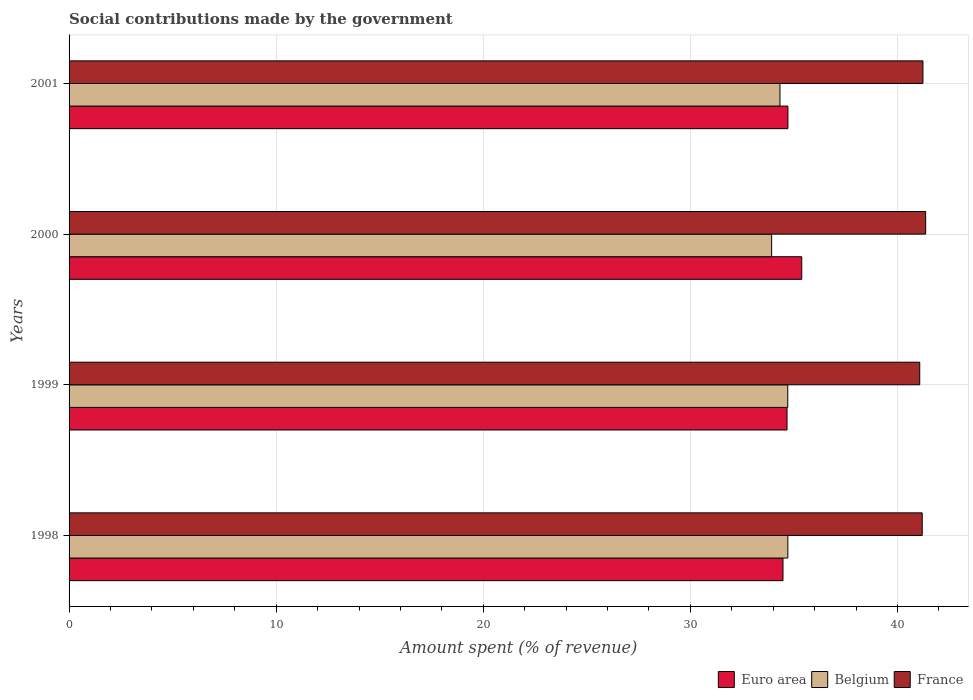How many different coloured bars are there?
Your response must be concise. 3. Are the number of bars per tick equal to the number of legend labels?
Keep it short and to the point. Yes. How many bars are there on the 2nd tick from the top?
Your answer should be very brief. 3. In how many cases, is the number of bars for a given year not equal to the number of legend labels?
Your answer should be compact. 0. What is the amount spent (in %) on social contributions in Euro area in 1998?
Offer a very short reply. 34.47. Across all years, what is the maximum amount spent (in %) on social contributions in Belgium?
Your response must be concise. 34.71. Across all years, what is the minimum amount spent (in %) on social contributions in France?
Your response must be concise. 41.08. In which year was the amount spent (in %) on social contributions in France maximum?
Your answer should be compact. 2000. What is the total amount spent (in %) on social contributions in Euro area in the graph?
Give a very brief answer. 139.23. What is the difference between the amount spent (in %) on social contributions in France in 1999 and that in 2001?
Ensure brevity in your answer.  -0.15. What is the difference between the amount spent (in %) on social contributions in France in 1998 and the amount spent (in %) on social contributions in Euro area in 2001?
Keep it short and to the point. 6.48. What is the average amount spent (in %) on social contributions in Belgium per year?
Your answer should be compact. 34.42. In the year 2001, what is the difference between the amount spent (in %) on social contributions in France and amount spent (in %) on social contributions in Euro area?
Offer a terse response. 6.52. What is the ratio of the amount spent (in %) on social contributions in Belgium in 1998 to that in 1999?
Make the answer very short. 1. Is the amount spent (in %) on social contributions in Euro area in 1999 less than that in 2000?
Your answer should be very brief. Yes. What is the difference between the highest and the second highest amount spent (in %) on social contributions in Belgium?
Ensure brevity in your answer.  0. What is the difference between the highest and the lowest amount spent (in %) on social contributions in France?
Your answer should be very brief. 0.29. What does the 3rd bar from the top in 2001 represents?
Your answer should be compact. Euro area. How many bars are there?
Make the answer very short. 12. How many years are there in the graph?
Ensure brevity in your answer.  4. What is the difference between two consecutive major ticks on the X-axis?
Provide a succinct answer. 10. Does the graph contain any zero values?
Offer a very short reply. No. Does the graph contain grids?
Give a very brief answer. Yes. Where does the legend appear in the graph?
Keep it short and to the point. Bottom right. How many legend labels are there?
Make the answer very short. 3. How are the legend labels stacked?
Offer a terse response. Horizontal. What is the title of the graph?
Offer a terse response. Social contributions made by the government. What is the label or title of the X-axis?
Provide a succinct answer. Amount spent (% of revenue). What is the label or title of the Y-axis?
Make the answer very short. Years. What is the Amount spent (% of revenue) of Euro area in 1998?
Provide a succinct answer. 34.47. What is the Amount spent (% of revenue) in Belgium in 1998?
Give a very brief answer. 34.71. What is the Amount spent (% of revenue) of France in 1998?
Provide a succinct answer. 41.2. What is the Amount spent (% of revenue) of Euro area in 1999?
Keep it short and to the point. 34.67. What is the Amount spent (% of revenue) of Belgium in 1999?
Your answer should be compact. 34.7. What is the Amount spent (% of revenue) of France in 1999?
Your answer should be compact. 41.08. What is the Amount spent (% of revenue) of Euro area in 2000?
Make the answer very short. 35.38. What is the Amount spent (% of revenue) of Belgium in 2000?
Ensure brevity in your answer.  33.93. What is the Amount spent (% of revenue) of France in 2000?
Ensure brevity in your answer.  41.36. What is the Amount spent (% of revenue) in Euro area in 2001?
Provide a short and direct response. 34.71. What is the Amount spent (% of revenue) of Belgium in 2001?
Ensure brevity in your answer.  34.33. What is the Amount spent (% of revenue) in France in 2001?
Offer a terse response. 41.23. Across all years, what is the maximum Amount spent (% of revenue) in Euro area?
Provide a short and direct response. 35.38. Across all years, what is the maximum Amount spent (% of revenue) in Belgium?
Your answer should be compact. 34.71. Across all years, what is the maximum Amount spent (% of revenue) in France?
Your answer should be compact. 41.36. Across all years, what is the minimum Amount spent (% of revenue) in Euro area?
Make the answer very short. 34.47. Across all years, what is the minimum Amount spent (% of revenue) of Belgium?
Your answer should be very brief. 33.93. Across all years, what is the minimum Amount spent (% of revenue) in France?
Ensure brevity in your answer.  41.08. What is the total Amount spent (% of revenue) of Euro area in the graph?
Offer a very short reply. 139.23. What is the total Amount spent (% of revenue) in Belgium in the graph?
Provide a succinct answer. 137.67. What is the total Amount spent (% of revenue) in France in the graph?
Give a very brief answer. 164.87. What is the difference between the Amount spent (% of revenue) in Euro area in 1998 and that in 1999?
Ensure brevity in your answer.  -0.2. What is the difference between the Amount spent (% of revenue) of Belgium in 1998 and that in 1999?
Provide a succinct answer. 0. What is the difference between the Amount spent (% of revenue) of France in 1998 and that in 1999?
Your answer should be compact. 0.12. What is the difference between the Amount spent (% of revenue) of Euro area in 1998 and that in 2000?
Give a very brief answer. -0.9. What is the difference between the Amount spent (% of revenue) in Belgium in 1998 and that in 2000?
Keep it short and to the point. 0.78. What is the difference between the Amount spent (% of revenue) of France in 1998 and that in 2000?
Provide a succinct answer. -0.17. What is the difference between the Amount spent (% of revenue) in Euro area in 1998 and that in 2001?
Ensure brevity in your answer.  -0.24. What is the difference between the Amount spent (% of revenue) in Belgium in 1998 and that in 2001?
Give a very brief answer. 0.38. What is the difference between the Amount spent (% of revenue) of France in 1998 and that in 2001?
Your answer should be compact. -0.03. What is the difference between the Amount spent (% of revenue) in Euro area in 1999 and that in 2000?
Your answer should be compact. -0.71. What is the difference between the Amount spent (% of revenue) of Belgium in 1999 and that in 2000?
Your response must be concise. 0.78. What is the difference between the Amount spent (% of revenue) in France in 1999 and that in 2000?
Offer a very short reply. -0.29. What is the difference between the Amount spent (% of revenue) of Euro area in 1999 and that in 2001?
Make the answer very short. -0.04. What is the difference between the Amount spent (% of revenue) of Belgium in 1999 and that in 2001?
Offer a very short reply. 0.38. What is the difference between the Amount spent (% of revenue) in France in 1999 and that in 2001?
Offer a terse response. -0.15. What is the difference between the Amount spent (% of revenue) of Euro area in 2000 and that in 2001?
Offer a terse response. 0.67. What is the difference between the Amount spent (% of revenue) of Belgium in 2000 and that in 2001?
Provide a succinct answer. -0.4. What is the difference between the Amount spent (% of revenue) in France in 2000 and that in 2001?
Offer a terse response. 0.13. What is the difference between the Amount spent (% of revenue) in Euro area in 1998 and the Amount spent (% of revenue) in Belgium in 1999?
Keep it short and to the point. -0.23. What is the difference between the Amount spent (% of revenue) of Euro area in 1998 and the Amount spent (% of revenue) of France in 1999?
Give a very brief answer. -6.6. What is the difference between the Amount spent (% of revenue) of Belgium in 1998 and the Amount spent (% of revenue) of France in 1999?
Provide a short and direct response. -6.37. What is the difference between the Amount spent (% of revenue) in Euro area in 1998 and the Amount spent (% of revenue) in Belgium in 2000?
Keep it short and to the point. 0.55. What is the difference between the Amount spent (% of revenue) of Euro area in 1998 and the Amount spent (% of revenue) of France in 2000?
Your answer should be very brief. -6.89. What is the difference between the Amount spent (% of revenue) of Belgium in 1998 and the Amount spent (% of revenue) of France in 2000?
Ensure brevity in your answer.  -6.66. What is the difference between the Amount spent (% of revenue) in Euro area in 1998 and the Amount spent (% of revenue) in Belgium in 2001?
Make the answer very short. 0.15. What is the difference between the Amount spent (% of revenue) in Euro area in 1998 and the Amount spent (% of revenue) in France in 2001?
Keep it short and to the point. -6.76. What is the difference between the Amount spent (% of revenue) of Belgium in 1998 and the Amount spent (% of revenue) of France in 2001?
Keep it short and to the point. -6.52. What is the difference between the Amount spent (% of revenue) in Euro area in 1999 and the Amount spent (% of revenue) in Belgium in 2000?
Provide a short and direct response. 0.74. What is the difference between the Amount spent (% of revenue) in Euro area in 1999 and the Amount spent (% of revenue) in France in 2000?
Offer a very short reply. -6.69. What is the difference between the Amount spent (% of revenue) of Belgium in 1999 and the Amount spent (% of revenue) of France in 2000?
Offer a terse response. -6.66. What is the difference between the Amount spent (% of revenue) of Euro area in 1999 and the Amount spent (% of revenue) of Belgium in 2001?
Offer a terse response. 0.34. What is the difference between the Amount spent (% of revenue) of Euro area in 1999 and the Amount spent (% of revenue) of France in 2001?
Ensure brevity in your answer.  -6.56. What is the difference between the Amount spent (% of revenue) of Belgium in 1999 and the Amount spent (% of revenue) of France in 2001?
Provide a succinct answer. -6.53. What is the difference between the Amount spent (% of revenue) in Euro area in 2000 and the Amount spent (% of revenue) in Belgium in 2001?
Make the answer very short. 1.05. What is the difference between the Amount spent (% of revenue) in Euro area in 2000 and the Amount spent (% of revenue) in France in 2001?
Offer a very short reply. -5.85. What is the difference between the Amount spent (% of revenue) in Belgium in 2000 and the Amount spent (% of revenue) in France in 2001?
Offer a very short reply. -7.31. What is the average Amount spent (% of revenue) in Euro area per year?
Your response must be concise. 34.81. What is the average Amount spent (% of revenue) of Belgium per year?
Make the answer very short. 34.42. What is the average Amount spent (% of revenue) in France per year?
Your answer should be compact. 41.22. In the year 1998, what is the difference between the Amount spent (% of revenue) of Euro area and Amount spent (% of revenue) of Belgium?
Keep it short and to the point. -0.23. In the year 1998, what is the difference between the Amount spent (% of revenue) of Euro area and Amount spent (% of revenue) of France?
Keep it short and to the point. -6.72. In the year 1998, what is the difference between the Amount spent (% of revenue) in Belgium and Amount spent (% of revenue) in France?
Your answer should be compact. -6.49. In the year 1999, what is the difference between the Amount spent (% of revenue) of Euro area and Amount spent (% of revenue) of Belgium?
Offer a very short reply. -0.04. In the year 1999, what is the difference between the Amount spent (% of revenue) in Euro area and Amount spent (% of revenue) in France?
Make the answer very short. -6.41. In the year 1999, what is the difference between the Amount spent (% of revenue) in Belgium and Amount spent (% of revenue) in France?
Provide a short and direct response. -6.37. In the year 2000, what is the difference between the Amount spent (% of revenue) in Euro area and Amount spent (% of revenue) in Belgium?
Give a very brief answer. 1.45. In the year 2000, what is the difference between the Amount spent (% of revenue) in Euro area and Amount spent (% of revenue) in France?
Keep it short and to the point. -5.98. In the year 2000, what is the difference between the Amount spent (% of revenue) in Belgium and Amount spent (% of revenue) in France?
Ensure brevity in your answer.  -7.44. In the year 2001, what is the difference between the Amount spent (% of revenue) in Euro area and Amount spent (% of revenue) in Belgium?
Ensure brevity in your answer.  0.38. In the year 2001, what is the difference between the Amount spent (% of revenue) in Euro area and Amount spent (% of revenue) in France?
Provide a succinct answer. -6.52. In the year 2001, what is the difference between the Amount spent (% of revenue) in Belgium and Amount spent (% of revenue) in France?
Your answer should be very brief. -6.9. What is the ratio of the Amount spent (% of revenue) of Euro area in 1998 to that in 1999?
Your answer should be compact. 0.99. What is the ratio of the Amount spent (% of revenue) of Euro area in 1998 to that in 2000?
Offer a terse response. 0.97. What is the ratio of the Amount spent (% of revenue) in Belgium in 1998 to that in 2000?
Offer a very short reply. 1.02. What is the ratio of the Amount spent (% of revenue) in France in 1998 to that in 2000?
Your answer should be compact. 1. What is the ratio of the Amount spent (% of revenue) in Euro area in 1998 to that in 2001?
Offer a very short reply. 0.99. What is the ratio of the Amount spent (% of revenue) of Belgium in 1998 to that in 2001?
Provide a succinct answer. 1.01. What is the ratio of the Amount spent (% of revenue) of France in 1998 to that in 2001?
Offer a terse response. 1. What is the ratio of the Amount spent (% of revenue) of Euro area in 1999 to that in 2000?
Provide a succinct answer. 0.98. What is the ratio of the Amount spent (% of revenue) in Euro area in 1999 to that in 2001?
Your answer should be very brief. 1. What is the ratio of the Amount spent (% of revenue) of Belgium in 1999 to that in 2001?
Provide a succinct answer. 1.01. What is the ratio of the Amount spent (% of revenue) in France in 1999 to that in 2001?
Your response must be concise. 1. What is the ratio of the Amount spent (% of revenue) of Euro area in 2000 to that in 2001?
Make the answer very short. 1.02. What is the ratio of the Amount spent (% of revenue) in Belgium in 2000 to that in 2001?
Provide a short and direct response. 0.99. What is the difference between the highest and the second highest Amount spent (% of revenue) of Euro area?
Offer a very short reply. 0.67. What is the difference between the highest and the second highest Amount spent (% of revenue) in Belgium?
Your answer should be compact. 0. What is the difference between the highest and the second highest Amount spent (% of revenue) in France?
Make the answer very short. 0.13. What is the difference between the highest and the lowest Amount spent (% of revenue) of Euro area?
Your answer should be compact. 0.9. What is the difference between the highest and the lowest Amount spent (% of revenue) in Belgium?
Keep it short and to the point. 0.78. What is the difference between the highest and the lowest Amount spent (% of revenue) of France?
Your response must be concise. 0.29. 